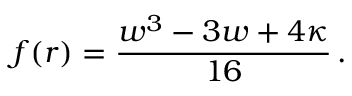Convert formula to latex. <formula><loc_0><loc_0><loc_500><loc_500>f ( r ) = \frac { w ^ { 3 } - 3 w + 4 \kappa } { 1 6 } \, .</formula> 